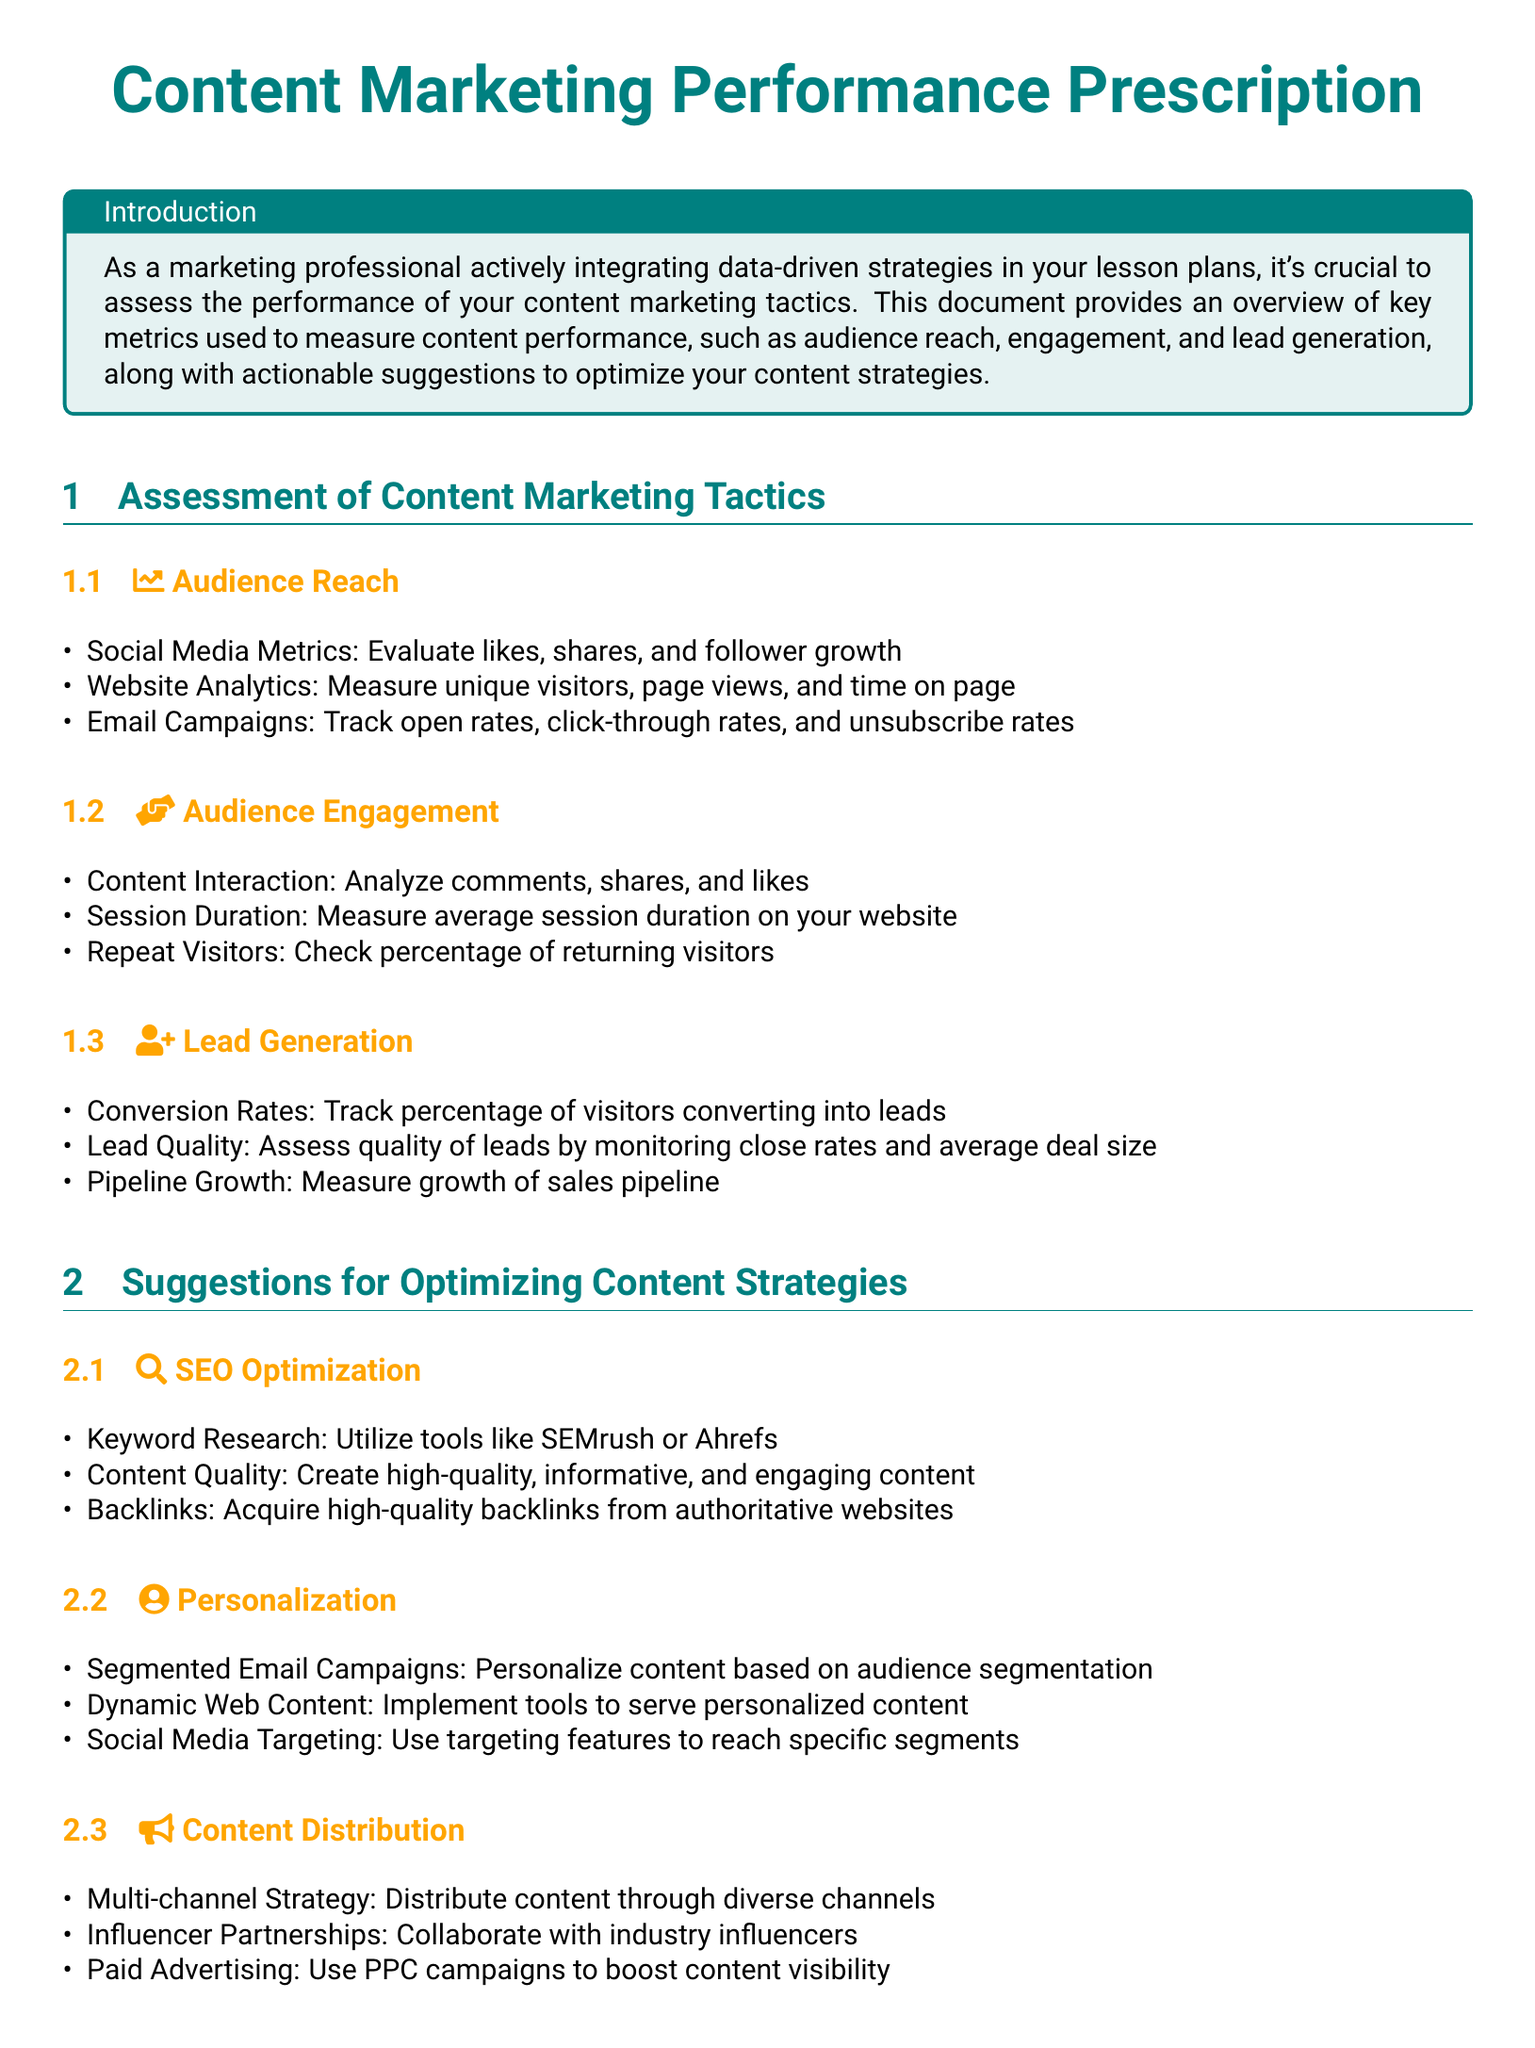What is the title of the document? The title of the document is prominently displayed at the top of the rendered document and emphasizes the theme of the content.
Answer: Content Marketing Performance Prescription What is one metric used to measure audience reach? The document lists specific metrics for assessing audience reach, providing examples of what to measure.
Answer: Unique visitors What aspect does the document suggest to analyze for audience engagement? The document specifies various performance metrics that indicate how well the content is being engaged with by the audience.
Answer: Content interaction What does the document recommend for assessing lead quality? The document identifies specific strategies for measuring lead quality, indicating how to analyze the effectiveness of leads generated.
Answer: Monitoring close rates Name a suggestion for optimizing content strategies. The document concludes with actionable suggestions that can enhance content marketing effectiveness, focusing on optimization techniques.
Answer: Keyword research What type of content distribution strategy is suggested? The document recommends a specific multi-faceted approach to how content should be shared across different platforms.
Answer: Multi-channel strategy How does the document suggest to personalize content for segmented email campaigns? The document mentions a method for tailoring content specifically to different audience segments as part of content optimization tactics.
Answer: Audience segmentation What color is used to highlight the title in the document? The document incorporates specific colors associated with distinct sections, including the title.
Answer: Main color 